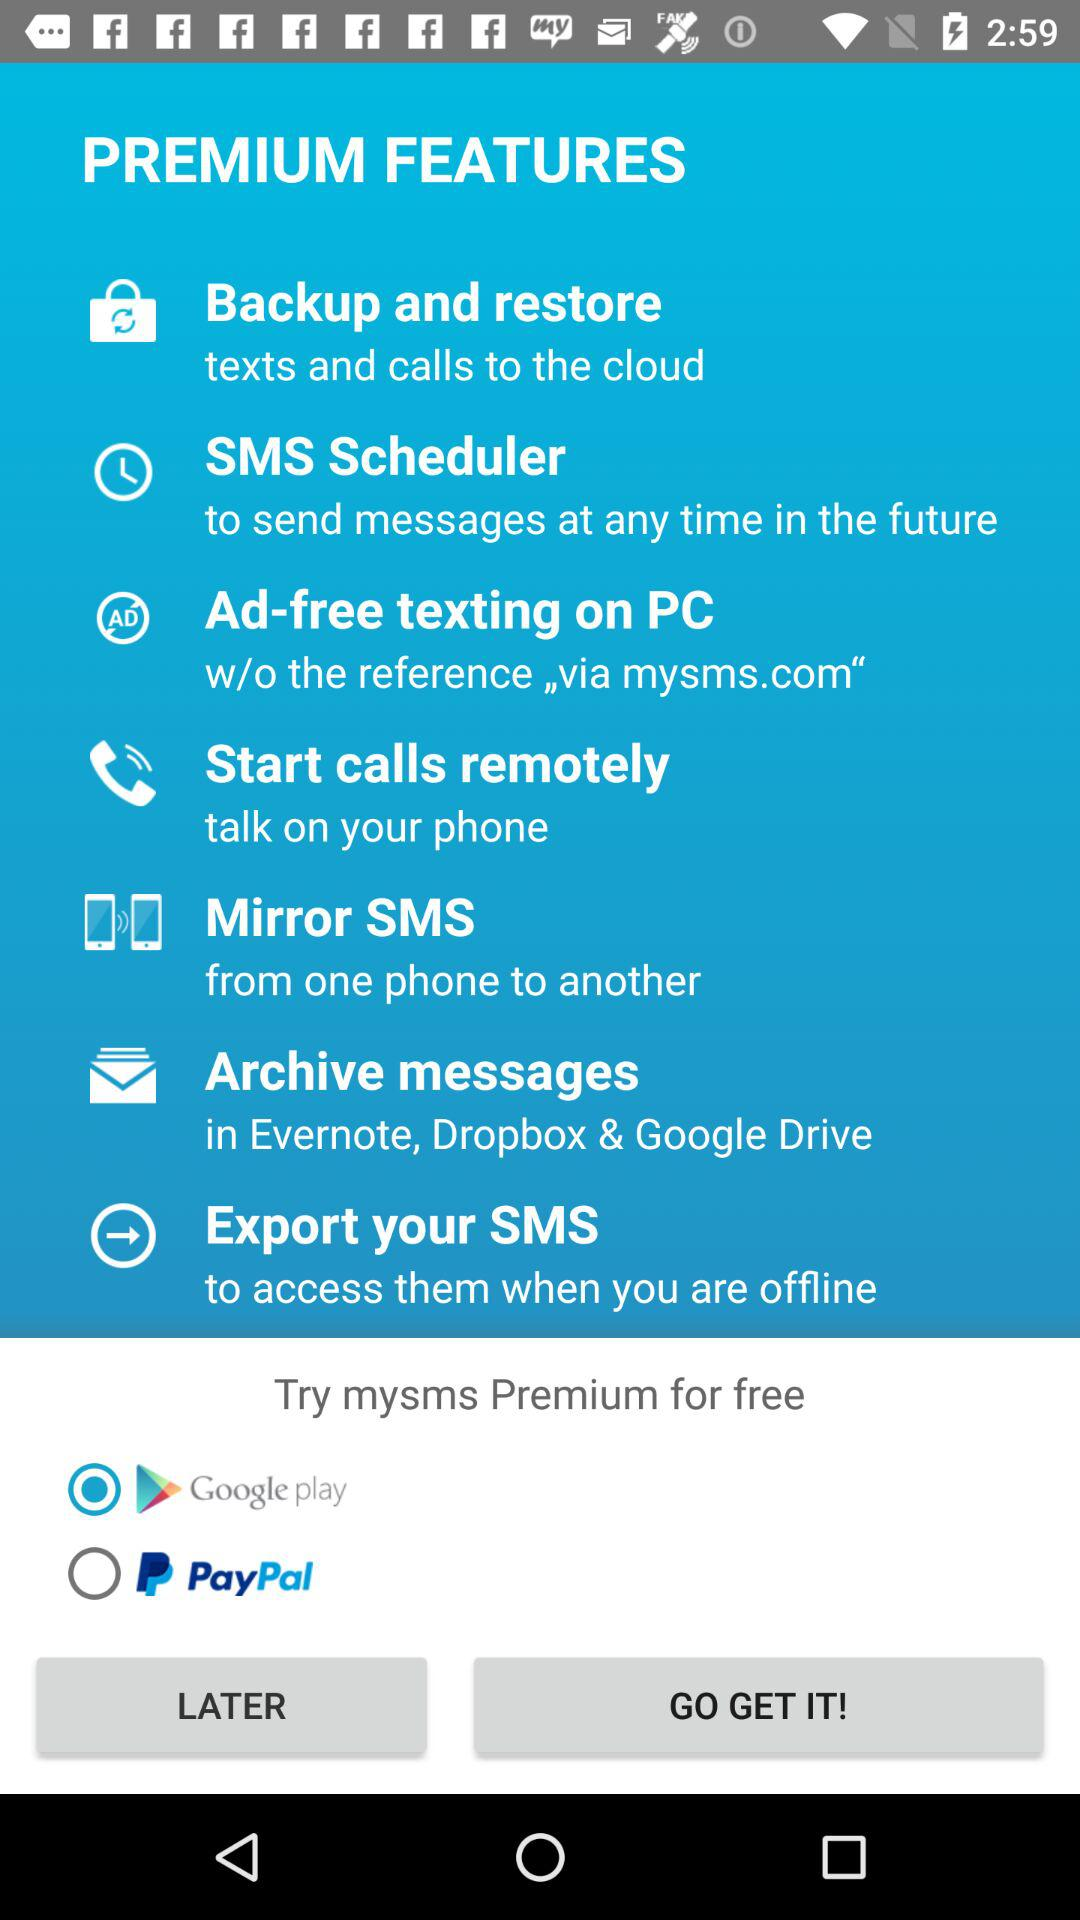How many messages have been scheduled?
When the provided information is insufficient, respond with <no answer>. <no answer> 